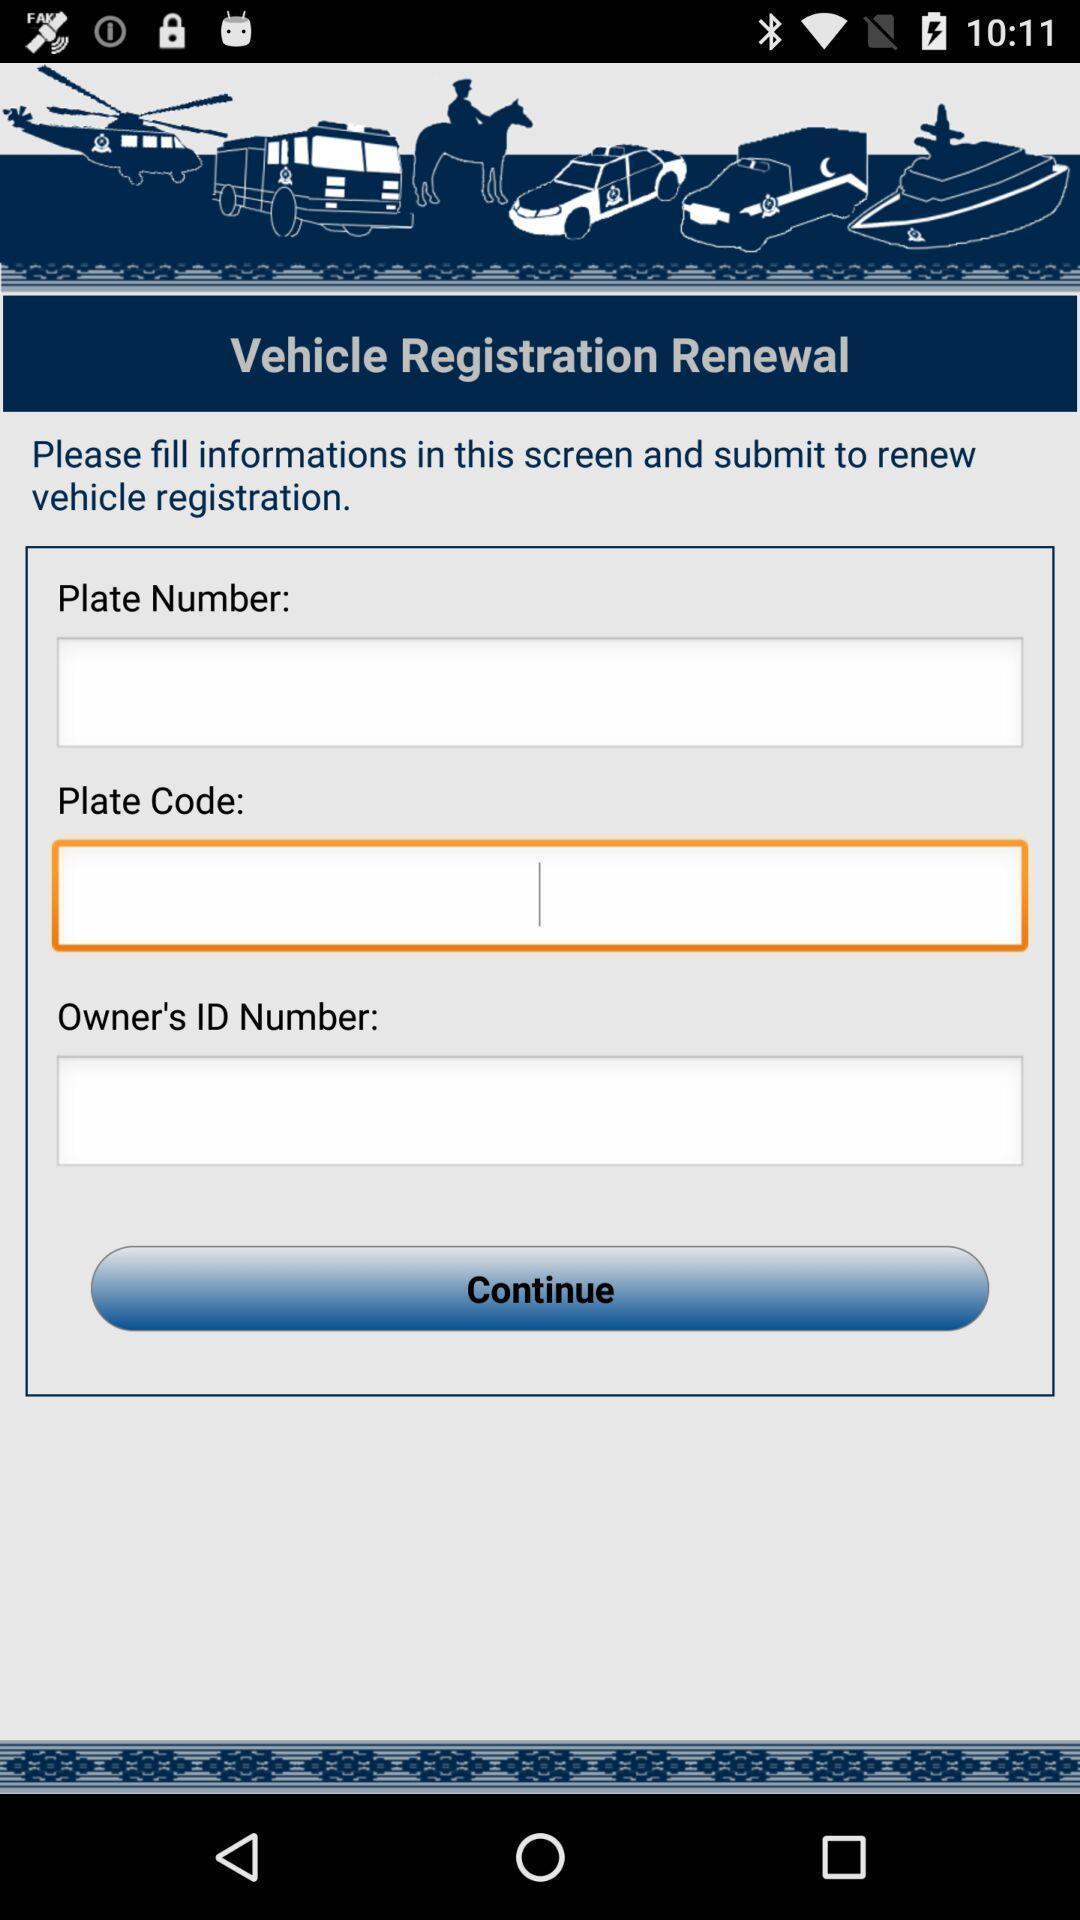Provide a description of this screenshot. Page with fields to enter vehicle registration info for renewal. 